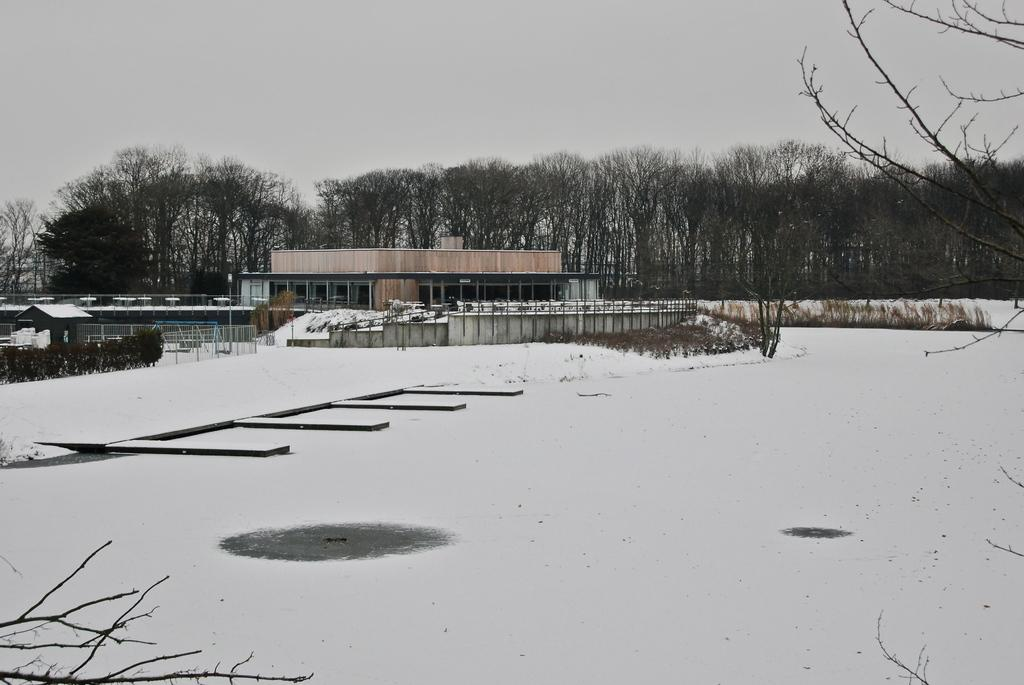Where was the picture taken? The picture was clicked outside the city. What is visible in the foreground of the image? There is snow in the foreground of the image. What can be seen in the center of the image? There are buildings and metal rods present in the center of the image. What is visible in the background of the image? There is a sky and trees visible in the background of the image. How many points are there on the metal rods in the image? There are no points mentioned on the metal rods in the image; they are simply described as being present in the center of the image. What time of day is it in the image, considering the minute hand on the clock? There is no clock or mention of time in the image, so it is not possible to determine the time of day. 